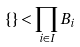<formula> <loc_0><loc_0><loc_500><loc_500>\{ \} < \prod _ { i \in I } B _ { i }</formula> 